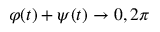<formula> <loc_0><loc_0><loc_500><loc_500>\varphi ( t ) + \psi ( t ) \rightarrow 0 , 2 \pi</formula> 